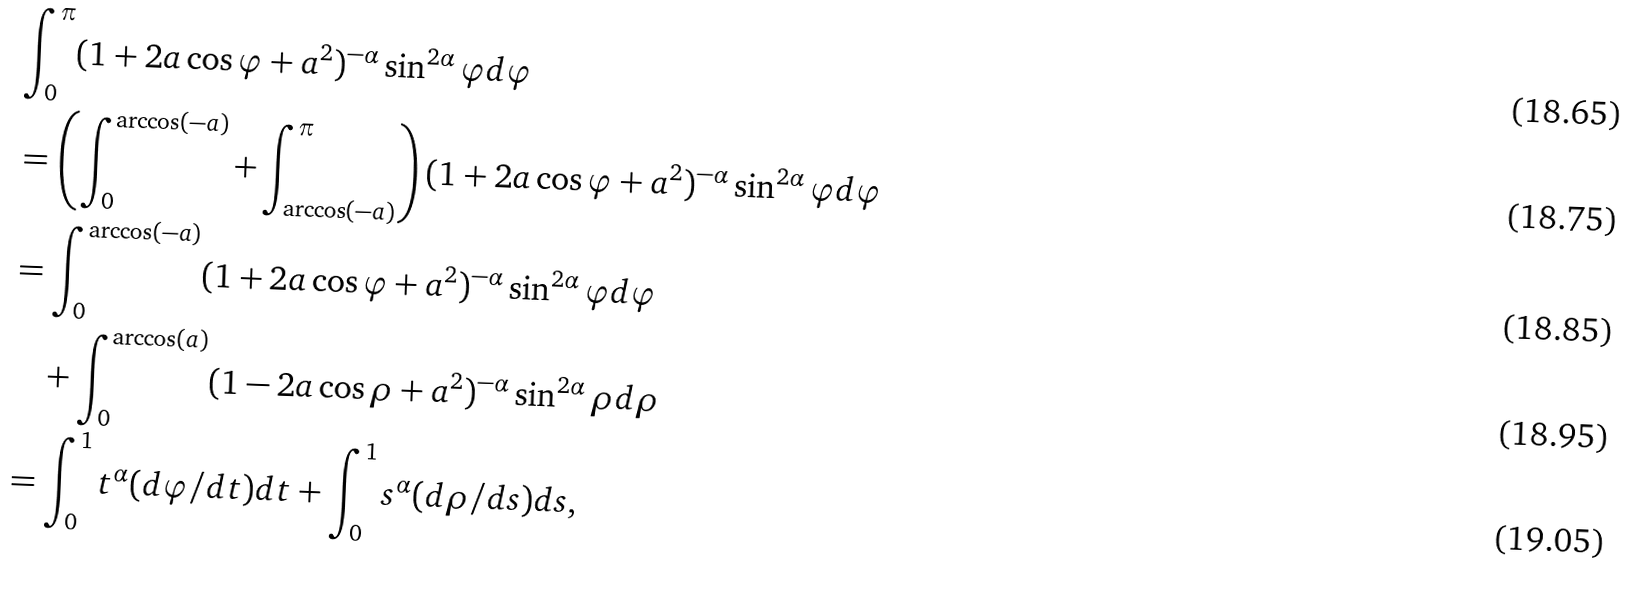<formula> <loc_0><loc_0><loc_500><loc_500>& \int _ { 0 } ^ { \pi } ( 1 + 2 a \cos \varphi + a ^ { 2 } ) ^ { - \alpha } \sin ^ { 2 \alpha } \varphi d \varphi \\ & = \left ( \int _ { 0 } ^ { \arccos ( - a ) } + \int _ { \arccos ( - a ) } ^ { \pi } \right ) ( 1 + 2 a \cos \varphi + a ^ { 2 } ) ^ { - \alpha } \sin ^ { 2 \alpha } \varphi d \varphi \\ & = \int _ { 0 } ^ { \arccos ( - a ) } ( 1 + 2 a \cos \varphi + a ^ { 2 } ) ^ { - \alpha } \sin ^ { 2 \alpha } \varphi d \varphi \\ & \quad + \int _ { 0 } ^ { \arccos ( a ) } ( 1 - 2 a \cos \rho + a ^ { 2 } ) ^ { - \alpha } \sin ^ { 2 \alpha } \rho d \rho \\ & = \int _ { 0 } ^ { 1 } t ^ { \alpha } ( d \varphi / d t ) d t + \int _ { 0 } ^ { 1 } s ^ { \alpha } ( d \rho / d s ) d s ,</formula> 